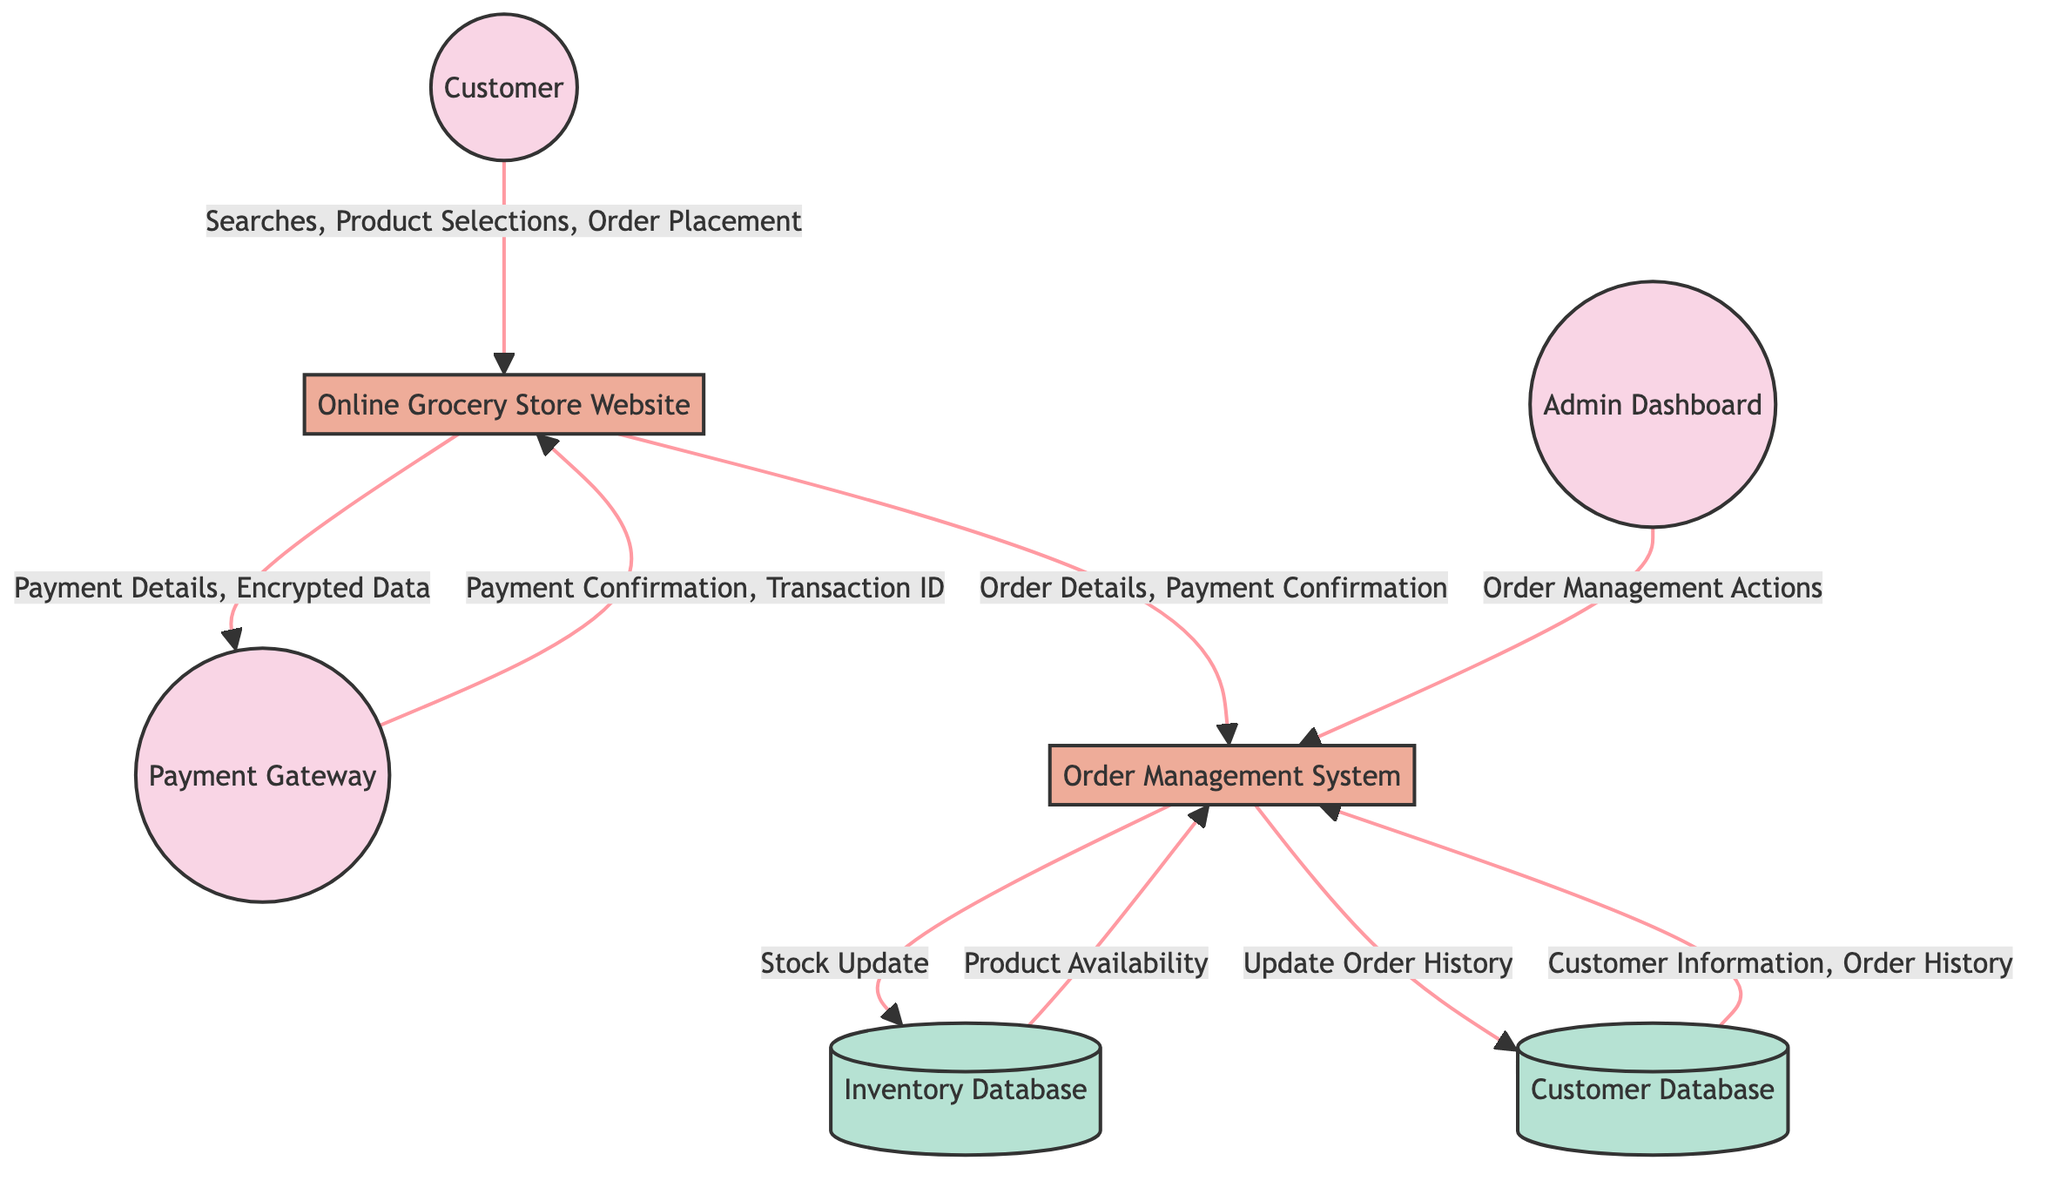What is the total number of nodes in the diagram? The diagram lists seven nodes: Customer, Online Grocery Store Website, Payment Gateway, Order Management System, Inventory Database, Customer Database, and Admin Dashboard. Therefore, the total number of nodes is seven.
Answer: 7 Which external entity interacts with the Online Grocery Store Website? The Customer is the external entity that interacts with the Online Grocery Store Website by searching for products, selecting items, and placing an order.
Answer: Customer What type of data flows from the Online Grocery Store Website to the Payment Gateway? The data that flows from the Online Grocery Store Website to the Payment Gateway includes Payment Details and Encrypted Data, indicating that this flow is related to payment processing.
Answer: Payment Details, Encrypted Data How many data flows are shown in the diagram? By examining the diagram, there are a total of eight distinct data flows between the various entities and processes, reflecting the interactions related to payment processing and order management.
Answer: 8 What does the Order Management System receive from the Customer Database? The Order Management System receives Customer Information and Order History from the Customer Database, which is crucial for processing orders accurately.
Answer: Customer Information, Order History Which process is responsible for updating the Inventory Database? The Order Management System is responsible for updating the Inventory Database by sending stock updates after an order is processed, ensuring that inventory levels are current.
Answer: Order Management System What type of entity is the Payment Gateway in the diagram? The Payment Gateway is categorized as an External Entity, which signifies that it operates outside the core processes of the online grocery store but is essential for payment processing.
Answer: External Entity What is the purpose of data flowing from the Admin Dashboard to the Order Management System? The data flow from the Admin Dashboard to the Order Management System includes Order Management Actions, which enable administrators to manage and control orders effectively.
Answer: Order Management Actions 